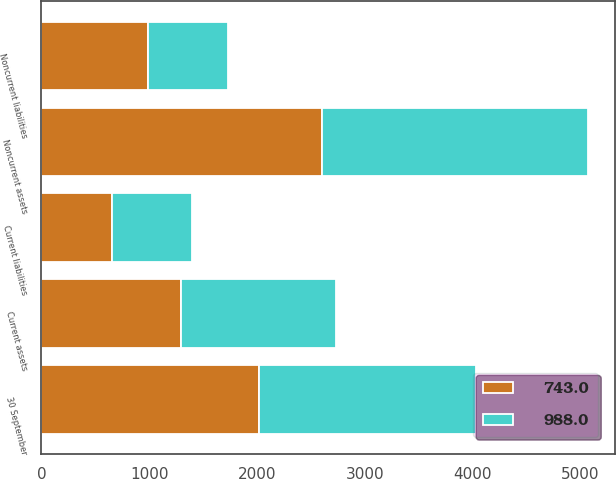Convert chart. <chart><loc_0><loc_0><loc_500><loc_500><stacked_bar_chart><ecel><fcel>30 September<fcel>Current assets<fcel>Noncurrent assets<fcel>Current liabilities<fcel>Noncurrent liabilities<nl><fcel>743<fcel>2015<fcel>1296.4<fcel>2607.4<fcel>654<fcel>988<nl><fcel>988<fcel>2014<fcel>1440<fcel>2464.6<fcel>745.2<fcel>743<nl></chart> 